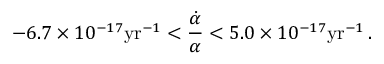<formula> <loc_0><loc_0><loc_500><loc_500>- 6 . 7 \times 1 0 ^ { - 1 7 } y r ^ { - 1 } < \frac { \dot { \alpha } } { \alpha } < 5 . 0 \times 1 0 ^ { - 1 7 } y r ^ { - 1 } \, .</formula> 